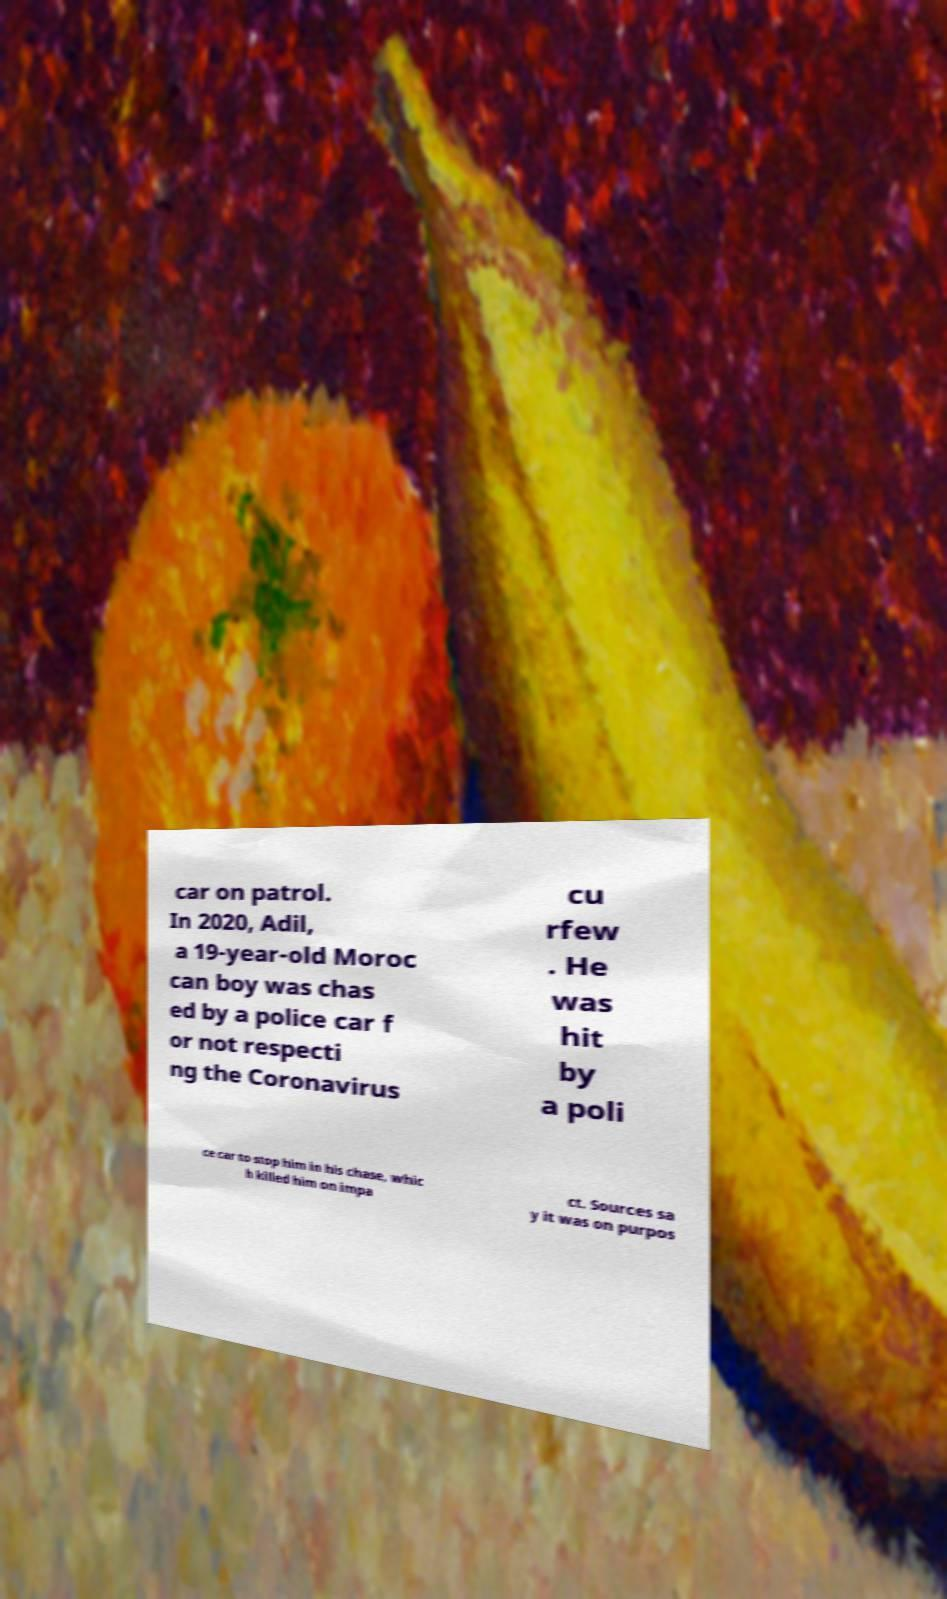Can you accurately transcribe the text from the provided image for me? car on patrol. In 2020, Adil, a 19-year-old Moroc can boy was chas ed by a police car f or not respecti ng the Coronavirus cu rfew . He was hit by a poli ce car to stop him in his chase, whic h killed him on impa ct. Sources sa y it was on purpos 